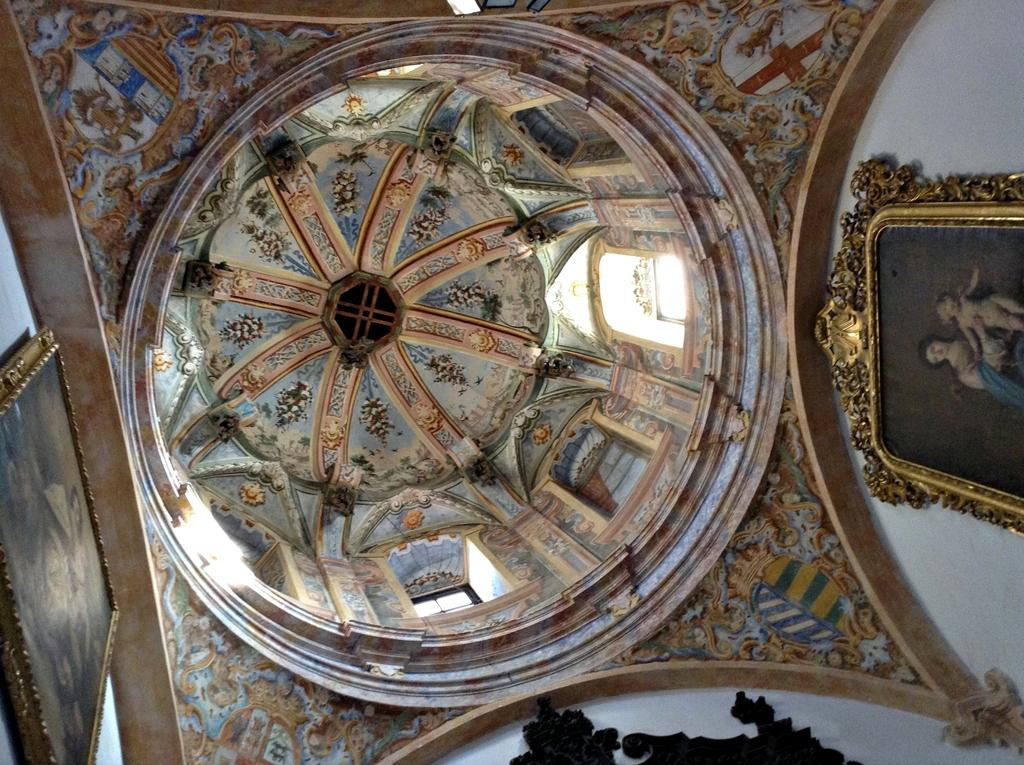What type of location is depicted in the image? The image shows an inside view of a building. What can be seen on the right side of the image? There are paintings on the right side of the image. What can be seen on the left side of the image? There are paintings on the left side of the image. What type of treatment is being administered to the arm in the image? There is no arm or treatment present in the image; it only shows paintings on both sides. 